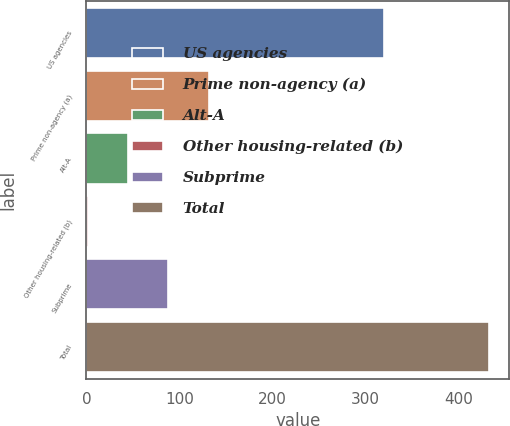Convert chart. <chart><loc_0><loc_0><loc_500><loc_500><bar_chart><fcel>US agencies<fcel>Prime non-agency (a)<fcel>Alt-A<fcel>Other housing-related (b)<fcel>Subprime<fcel>Total<nl><fcel>320<fcel>131.3<fcel>45.1<fcel>2<fcel>88.2<fcel>433<nl></chart> 